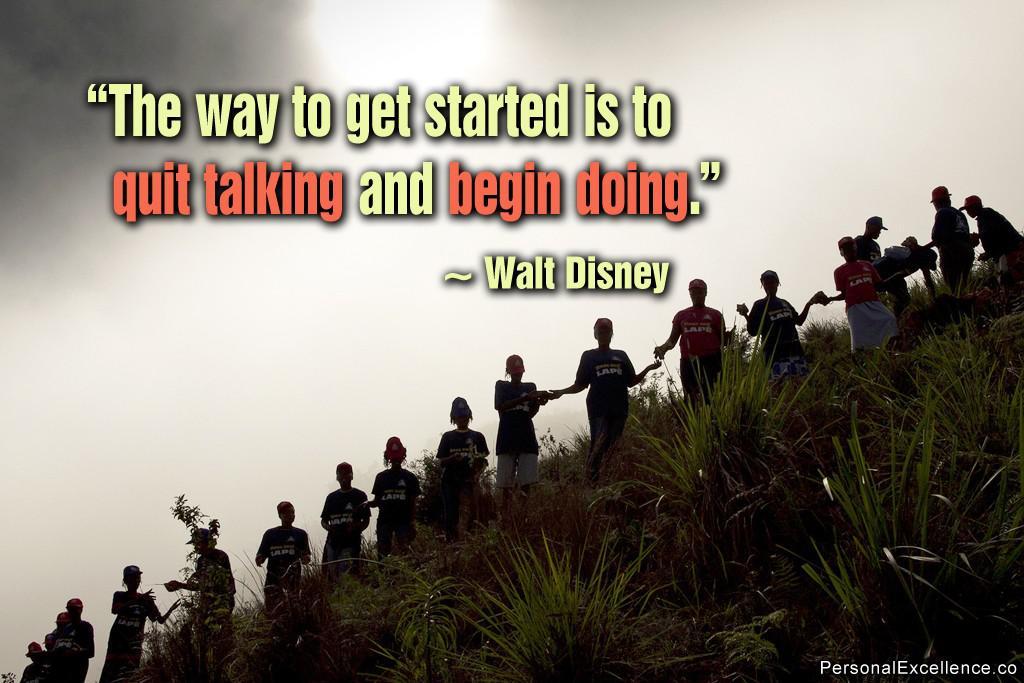Who said the quote?
Your answer should be compact. Walt disney. What does the second group of red text say?
Offer a terse response. Begin doing. 